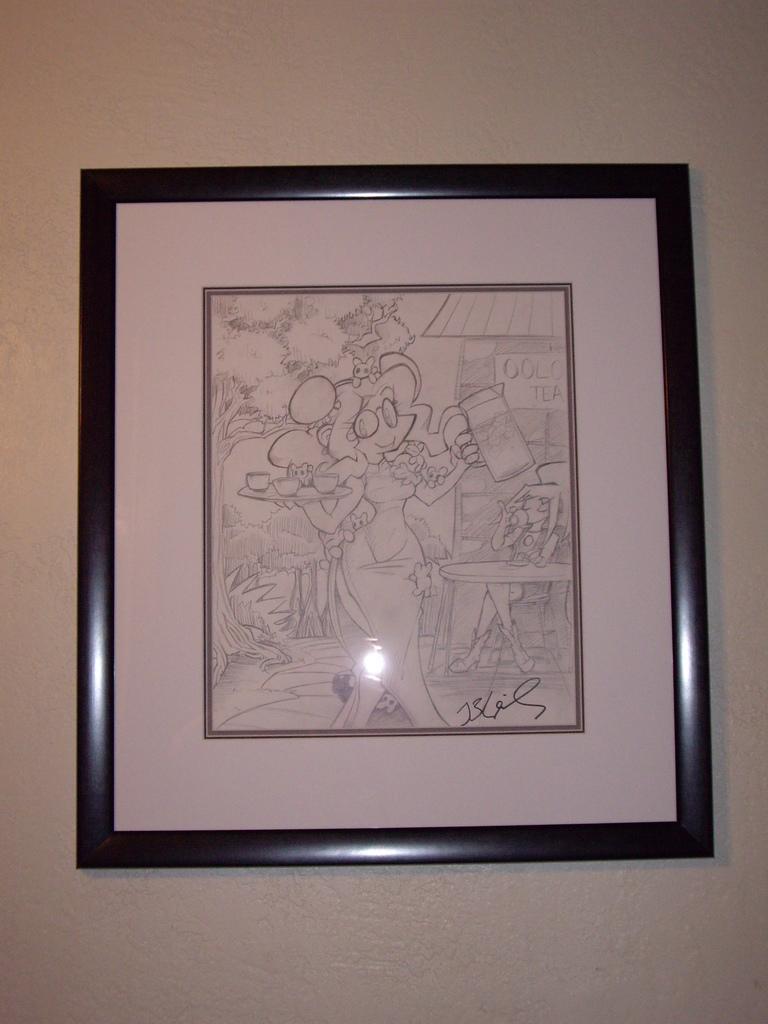How would you summarize this image in a sentence or two? In this image we can see frame is attached to the wall. 